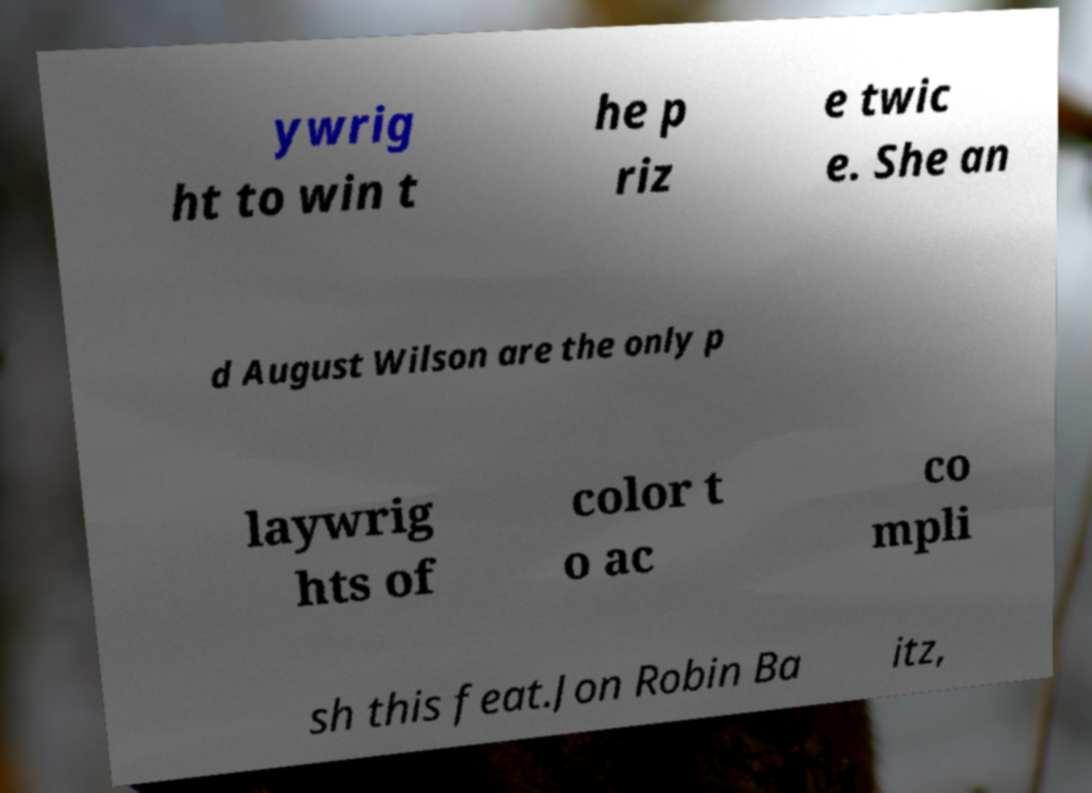Please identify and transcribe the text found in this image. ywrig ht to win t he p riz e twic e. She an d August Wilson are the only p laywrig hts of color t o ac co mpli sh this feat.Jon Robin Ba itz, 